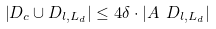<formula> <loc_0><loc_0><loc_500><loc_500>\left | D _ { c } \cup D _ { l , L _ { d } } \right | \leq 4 \delta \cdot \left | A \ D _ { l , L _ { d } } \right |</formula> 